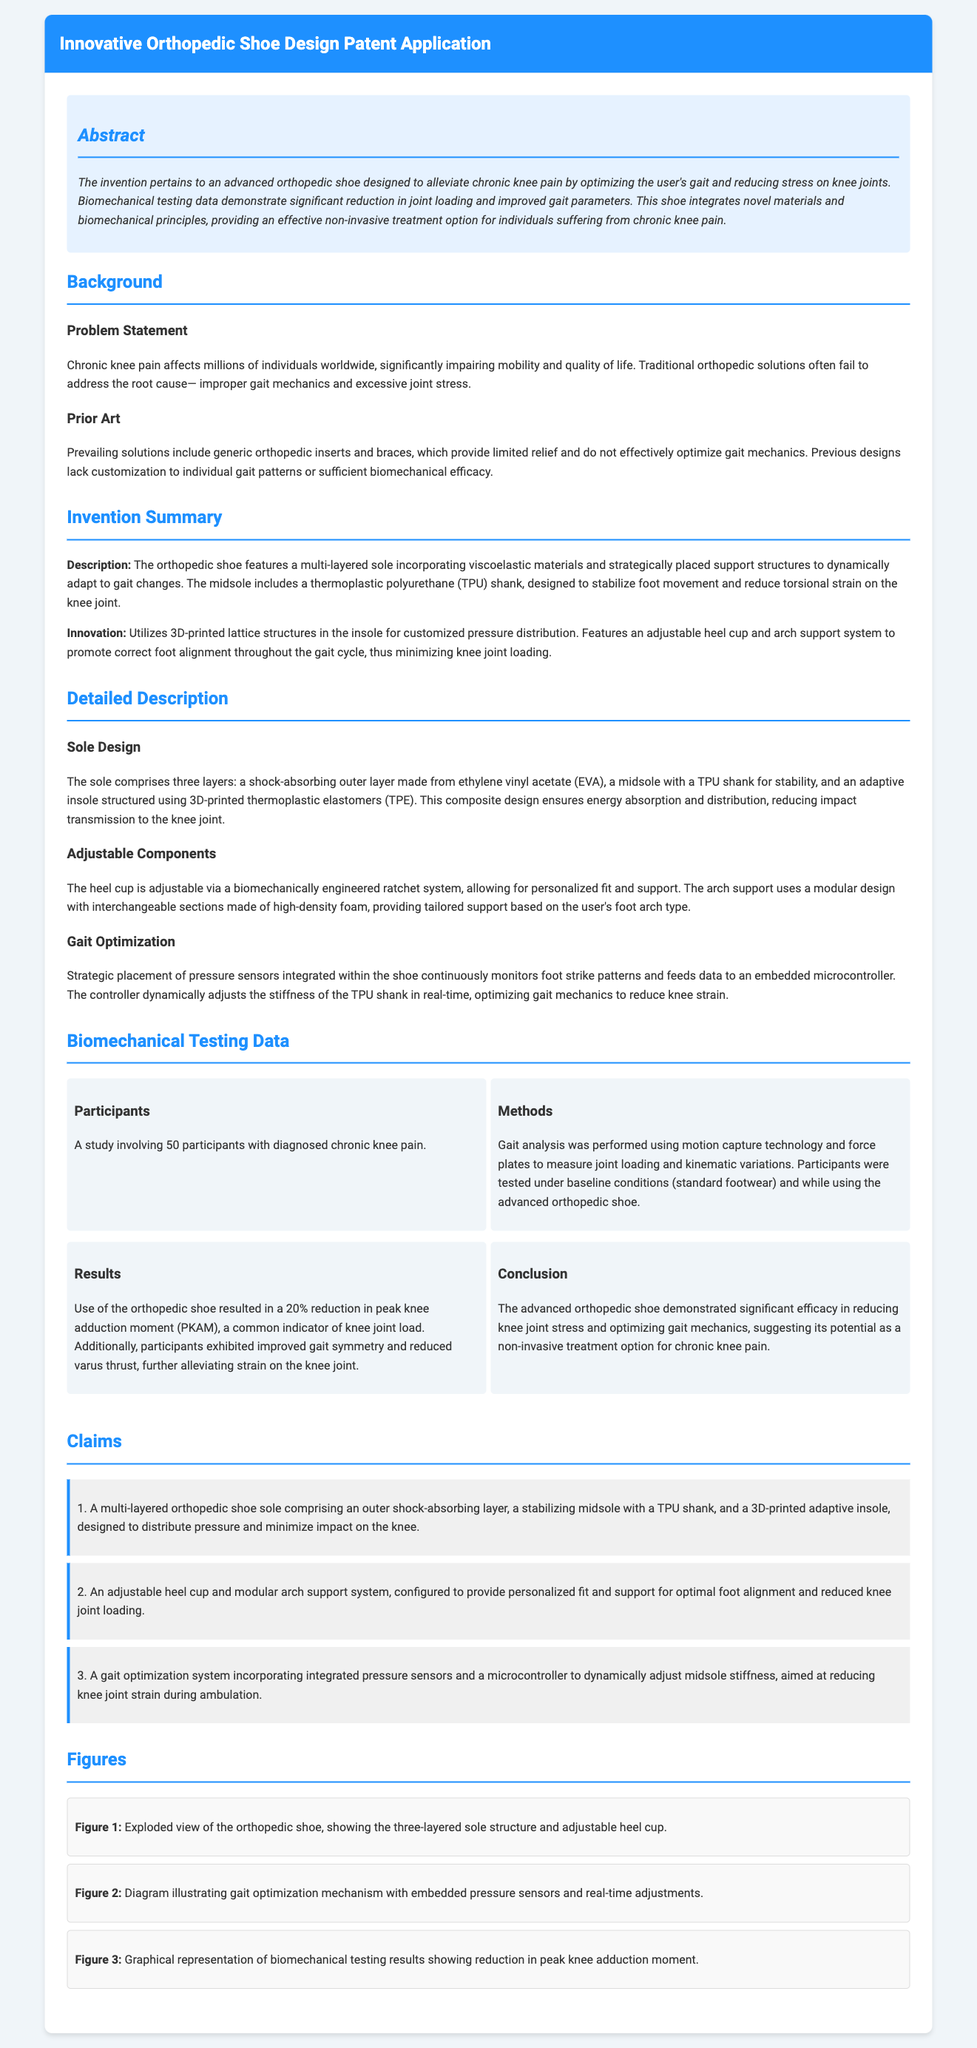What is the primary purpose of the orthopedic shoe? The purpose is to alleviate chronic knee pain by optimizing the user's gait and reducing stress on knee joints.
Answer: Alleviate chronic knee pain How many participants were involved in the biomechanical testing? The number of participants involved in the study is stated in the biomechanical testing data section.
Answer: 50 participants What material is used in the midsole? The midsole includes a thermoplastic polyurethane (TPU) shank designed for stability.
Answer: Thermoplastic polyurethane (TPU) What is the percentage reduction in peak knee adduction moment? The results section reports a specific percentage reduction in peak knee adduction moment when using the orthopedic shoe.
Answer: 20% What does the adjustable heel cup allow for? The adjustable heel cup is designed to provide personalized fit and support for the user.
Answer: Personalized fit and support What technology was utilized for gait analysis? The methods section mentions specific technology used for measuring joint loading and kinematic variations during the study.
Answer: Motion capture technology and force plates Which innovative feature helps customize pressure distribution? The feature mentioned in the invention summary that allows for customized pressure distribution is highlighted in terms of its technology.
Answer: 3D-printed lattice structures What type of system dynamically adjusts midsole stiffness? The gait optimization system is described to include a mechanism that dynamically adjusts the footwear's midsole stiffness.
Answer: Gait optimization system 